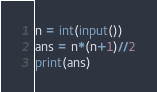<code> <loc_0><loc_0><loc_500><loc_500><_Python_>n = int(input())
ans = n*(n+1)//2
print(ans)</code> 